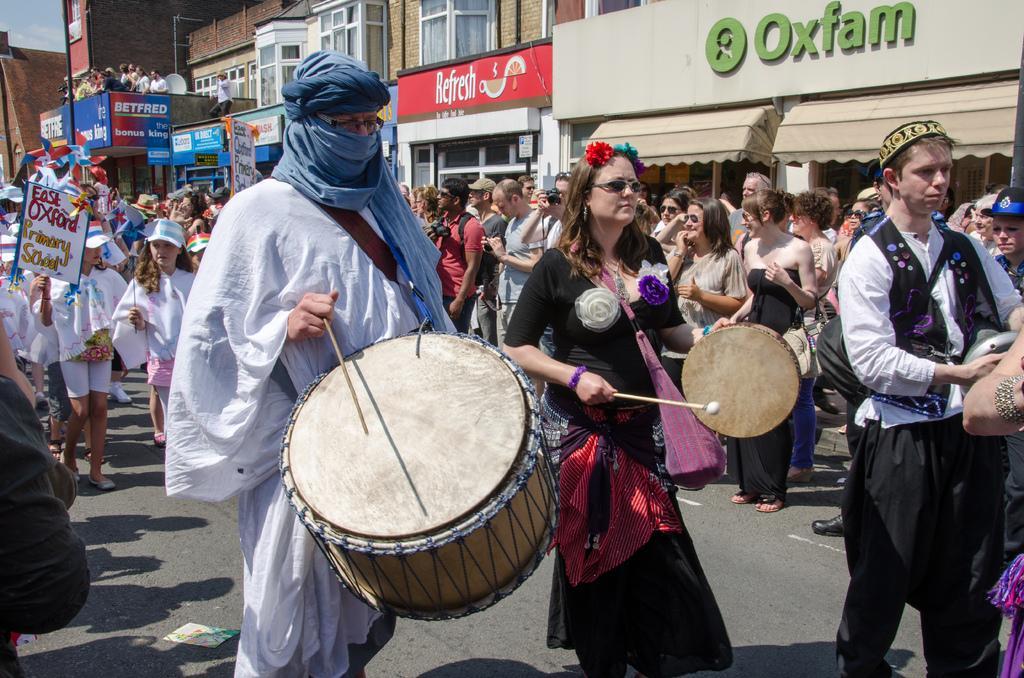Please provide a concise description of this image. This is completely an outdoor picture. On the background of the picture we can see few buildings and these are hoardings. On the road we can see all the persons standing. few are walking and few are playing drums. 